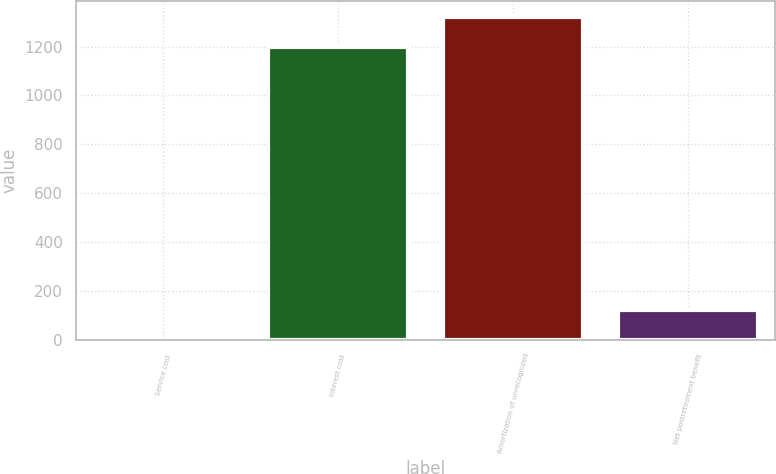Convert chart. <chart><loc_0><loc_0><loc_500><loc_500><bar_chart><fcel>Service cost<fcel>Interest cost<fcel>Amortization of unrecognized<fcel>Net postretirement benefit<nl><fcel>3<fcel>1200<fcel>1321.7<fcel>124.7<nl></chart> 